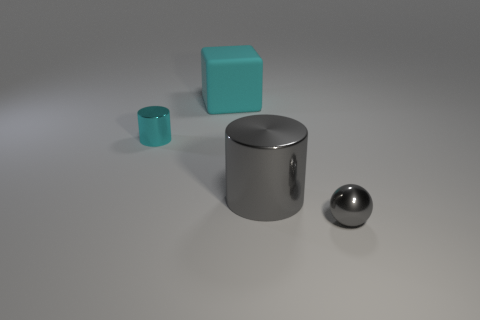There is a sphere that is in front of the big metal cylinder; is it the same color as the large metallic cylinder?
Give a very brief answer. Yes. Does the small gray ball have the same material as the small cyan thing?
Provide a succinct answer. Yes. The big object behind the cylinder that is right of the large thing to the left of the large gray cylinder is what shape?
Keep it short and to the point. Cube. Is the large object that is on the right side of the matte block made of the same material as the big cube behind the small gray thing?
Offer a very short reply. No. What is the small cylinder made of?
Provide a succinct answer. Metal. How many other things are the same shape as the big metallic object?
Your answer should be compact. 1. There is a large cylinder that is the same color as the metal sphere; what is it made of?
Give a very brief answer. Metal. Are there any other things that are the same shape as the big metal object?
Your answer should be compact. Yes. The tiny metallic object in front of the small metallic object that is behind the metallic thing that is in front of the large gray object is what color?
Your response must be concise. Gray. How many big objects are cyan objects or balls?
Offer a terse response. 1. 